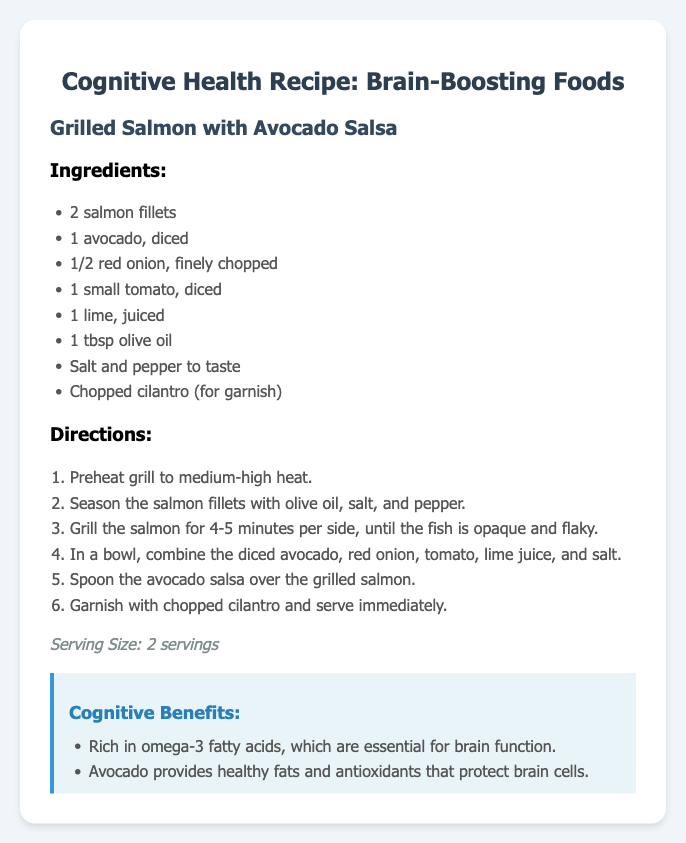What is the main dish of the recipe? The title of the dish is presented prominently in the document, which is "Grilled Salmon with Avocado Salsa."
Answer: Grilled Salmon with Avocado Salsa How many salmon fillets are needed? The ingredients list specifies the quantity of salmon fillets required for the recipe, which is two.
Answer: 2 What is the serving size? The serving size is clearly stated in the document.
Answer: 2 servings What ingredient provides healthy fats and antioxidants? The ingredient list mentions avocado, which is known for its healthy fats and antioxidants.
Answer: Avocado How long should the salmon be grilled per side? The directions indicate the grilling time for the salmon fillets, which is four to five minutes per side.
Answer: 4-5 minutes What is a key benefit of consuming omega-3 fatty acids? The cognitive benefits section highlights that omega-3 fatty acids are essential for brain function.
Answer: Brain function What ingredient is used to season the salmon? The document lists olive oil, salt, and pepper as seasonings for the salmon.
Answer: Olive oil, salt, and pepper Which nutrient does avocado provide that protects brain cells? The cognitive benefits section mentions that avocado provides antioxidants that protect brain cells.
Answer: Antioxidants 